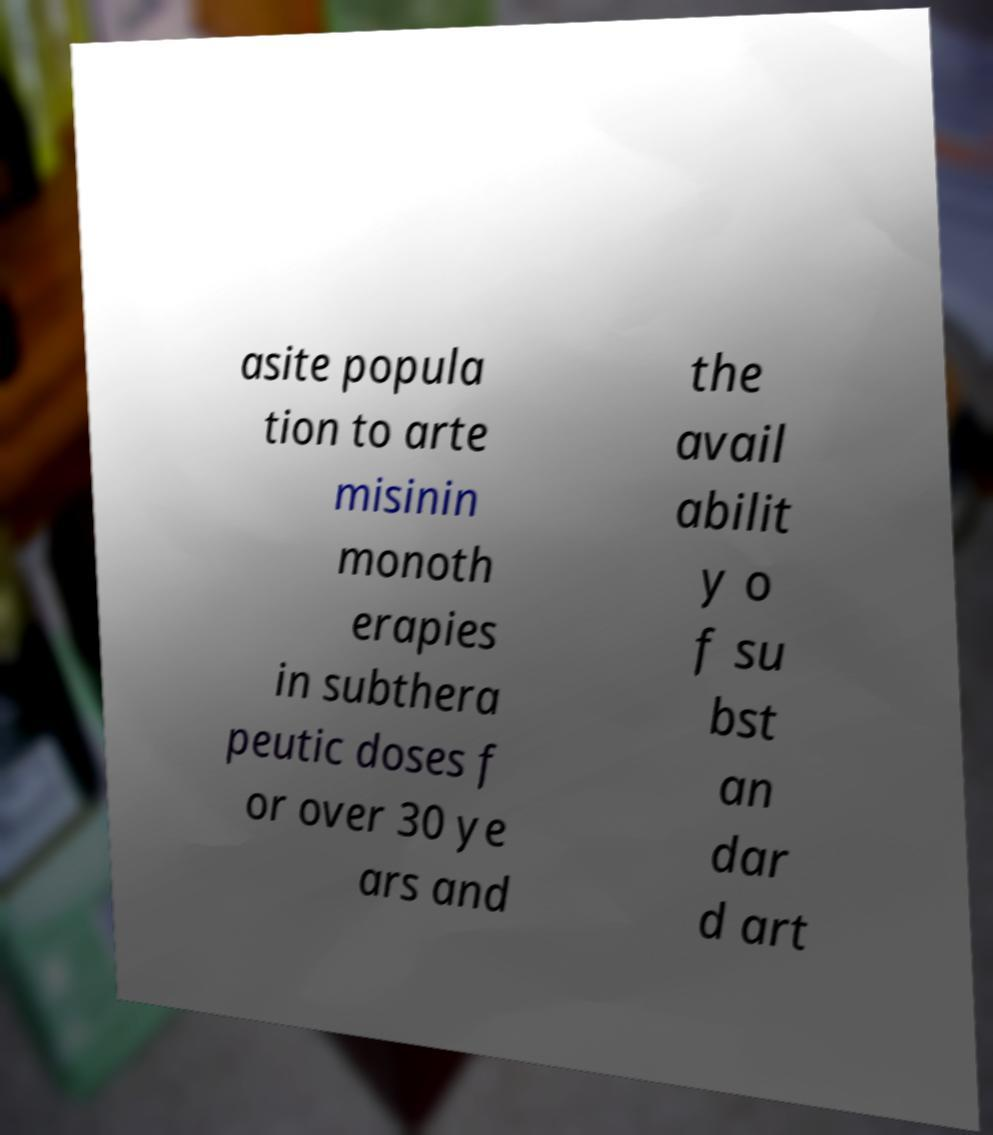Can you accurately transcribe the text from the provided image for me? asite popula tion to arte misinin monoth erapies in subthera peutic doses f or over 30 ye ars and the avail abilit y o f su bst an dar d art 